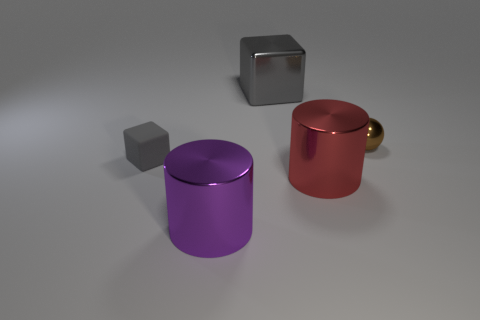Add 5 red metallic objects. How many objects exist? 10 Subtract all green cylinders. Subtract all green balls. How many cylinders are left? 2 Subtract all gray cylinders. How many green cubes are left? 0 Add 2 rubber blocks. How many rubber blocks exist? 3 Subtract all purple cylinders. How many cylinders are left? 1 Subtract 0 blue blocks. How many objects are left? 5 Subtract all cubes. How many objects are left? 3 Subtract 1 blocks. How many blocks are left? 1 Subtract all metal cylinders. Subtract all big red metallic things. How many objects are left? 2 Add 4 gray matte cubes. How many gray matte cubes are left? 5 